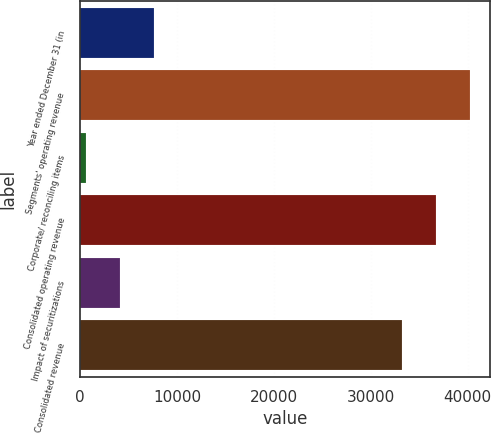Convert chart to OTSL. <chart><loc_0><loc_0><loc_500><loc_500><bar_chart><fcel>Year ended December 31 (in<fcel>Segments' operating revenue<fcel>Corporate/ reconciling items<fcel>Consolidated operating revenue<fcel>Impact of securitizations<fcel>Consolidated revenue<nl><fcel>7651.2<fcel>40281.2<fcel>626<fcel>36768.6<fcel>4138.6<fcel>33256<nl></chart> 